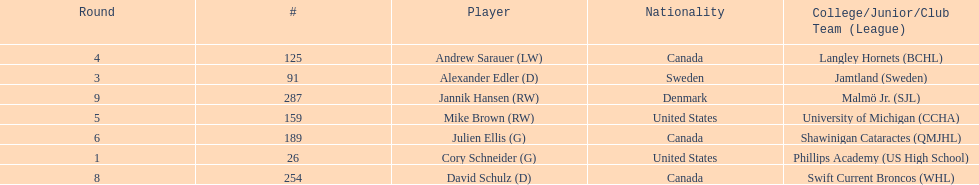Which player was the first player to be drafted? Cory Schneider (G). 